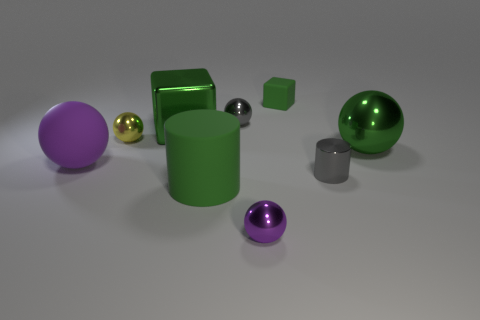What time of day does the lighting in this image suggest? The lighting in the image appears neutral and even, like that typically seen in a studio setting. It does not strongly imply a particular time of day but offers soft shadows indicative of a diffuse light source. 